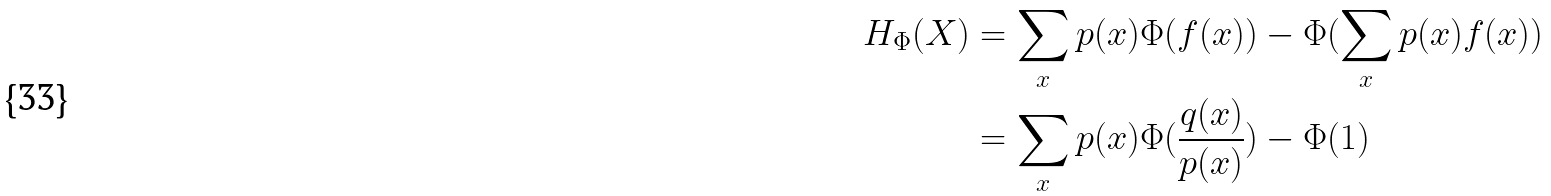<formula> <loc_0><loc_0><loc_500><loc_500>H _ { \Phi } ( X ) & = \sum _ { x } p ( x ) \Phi ( f ( x ) ) - \Phi ( \sum _ { x } p ( x ) f ( x ) ) \\ & = \sum _ { x } p ( x ) \Phi ( \frac { q ( x ) } { p ( x ) } ) - \Phi ( 1 )</formula> 